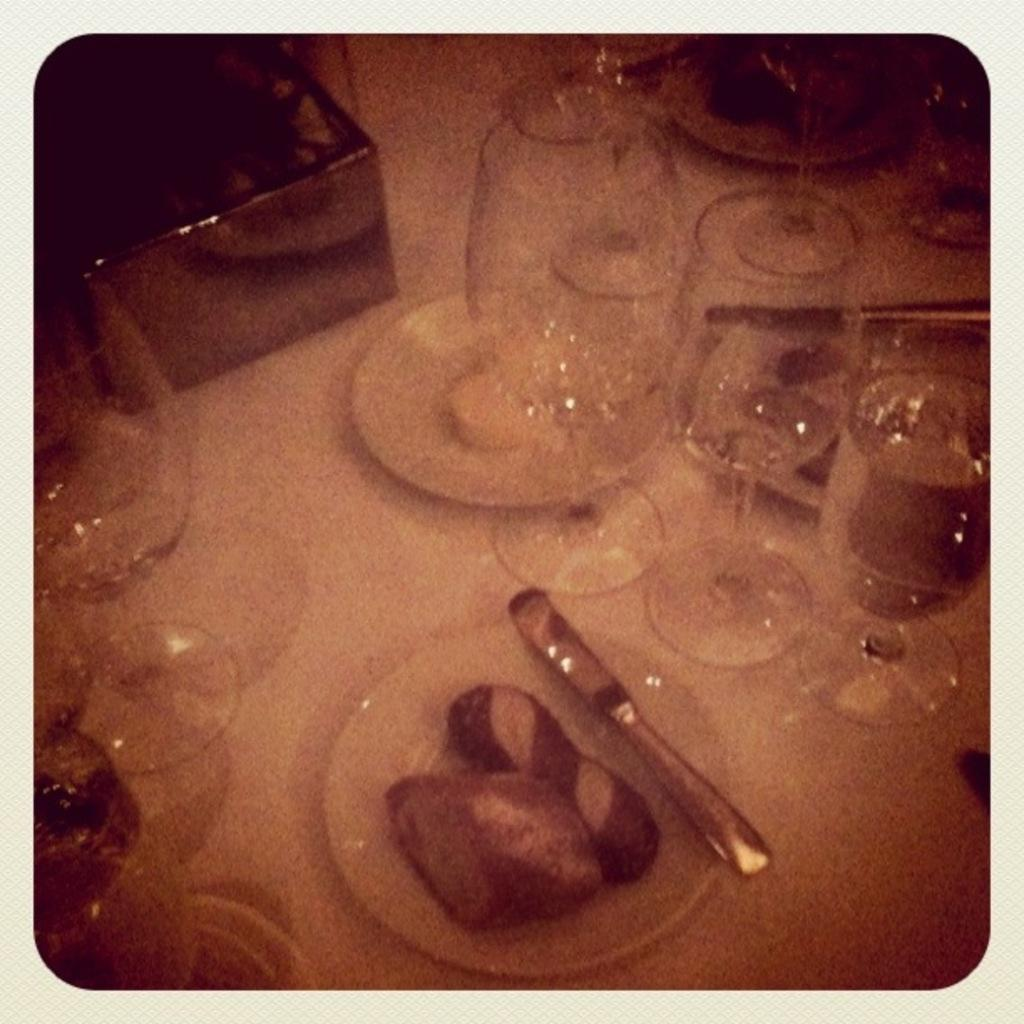What is the main subject in the center of the image? There is an object in the center of the image. What can be seen on the object? Glasses and food items are present on the object. Are there any other objects on the object? Yes, there are other objects on the object. Can you tell me how many hooks are attached to the shelf in the image? There is no shelf or hook present in the image; the main subject is an object with glasses, food items, and other objects on it. 